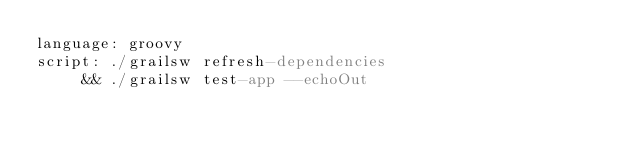Convert code to text. <code><loc_0><loc_0><loc_500><loc_500><_YAML_>language: groovy
script: ./grailsw refresh-dependencies
     && ./grailsw test-app --echoOut</code> 